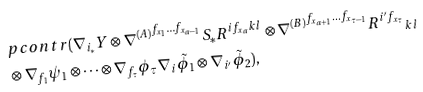<formula> <loc_0><loc_0><loc_500><loc_500>& p c o n t r ( \nabla _ { i _ { * } } Y \otimes { \nabla ^ { ( A ) } } ^ { f _ { x _ { 1 } } \dots f _ { x _ { a - 1 } } } S _ { * } R ^ { i f _ { x _ { a } } k l } \otimes { \nabla ^ { ( B ) } } ^ { f _ { x _ { a + 1 } } \dots f _ { x _ { \tau - 1 } } } { R ^ { i ^ { \prime } f _ { x _ { \tau } } } } _ { k l } \\ & \otimes \nabla _ { f _ { 1 } } \psi _ { 1 } \otimes \dots \otimes \nabla _ { f _ { \tau } } \phi _ { \tau } \nabla _ { i } \tilde { \phi } _ { 1 } \otimes \nabla _ { i ^ { \prime } } \tilde { \phi } _ { 2 } ) ,</formula> 